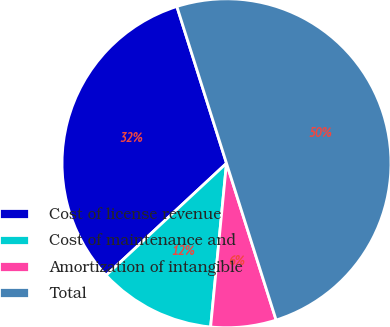<chart> <loc_0><loc_0><loc_500><loc_500><pie_chart><fcel>Cost of license revenue<fcel>Cost of maintenance and<fcel>Amortization of intangible<fcel>Total<nl><fcel>32.05%<fcel>11.53%<fcel>6.42%<fcel>50.0%<nl></chart> 